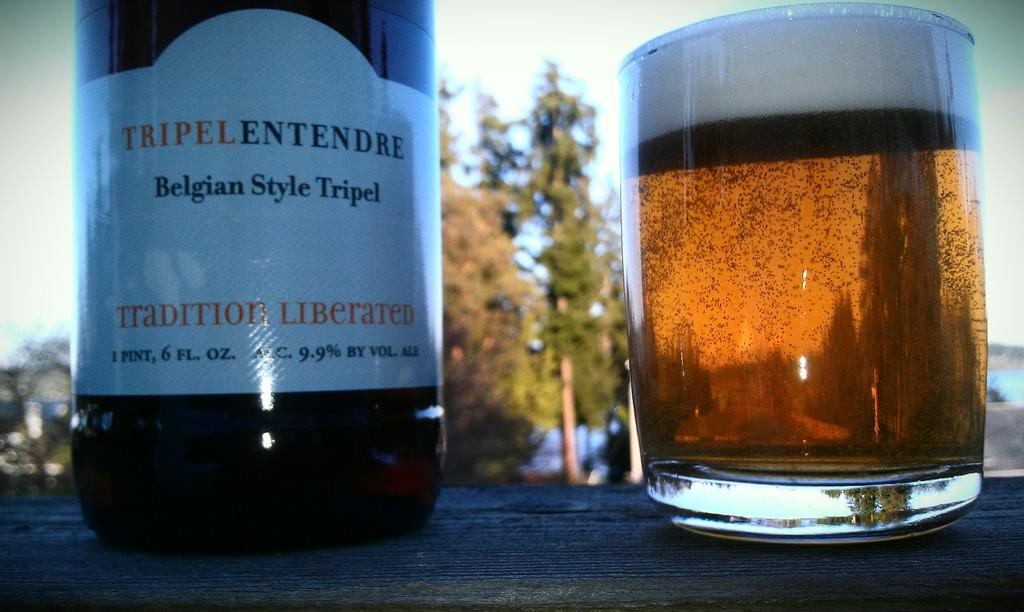What objects are present in the image? There is a bottle and a glass in the image. What is the color of the surface on which the objects are placed? The objects are on a black color surface. What can be seen in the background of the image? There are trees in the background of the image. What is the color of the sky in the image? The sky is blue and white in color. What type of sponge is being used to clean the bottle in the image? There is no sponge present in the image, and the bottle is not being cleaned. What religious symbol can be seen in the image? There are no religious symbols present in the image. 